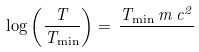<formula> <loc_0><loc_0><loc_500><loc_500>\log \left ( \frac { T } { T _ { \min } } \right ) = \, \frac { T _ { \min } \, m \, c ^ { 2 } } { }</formula> 